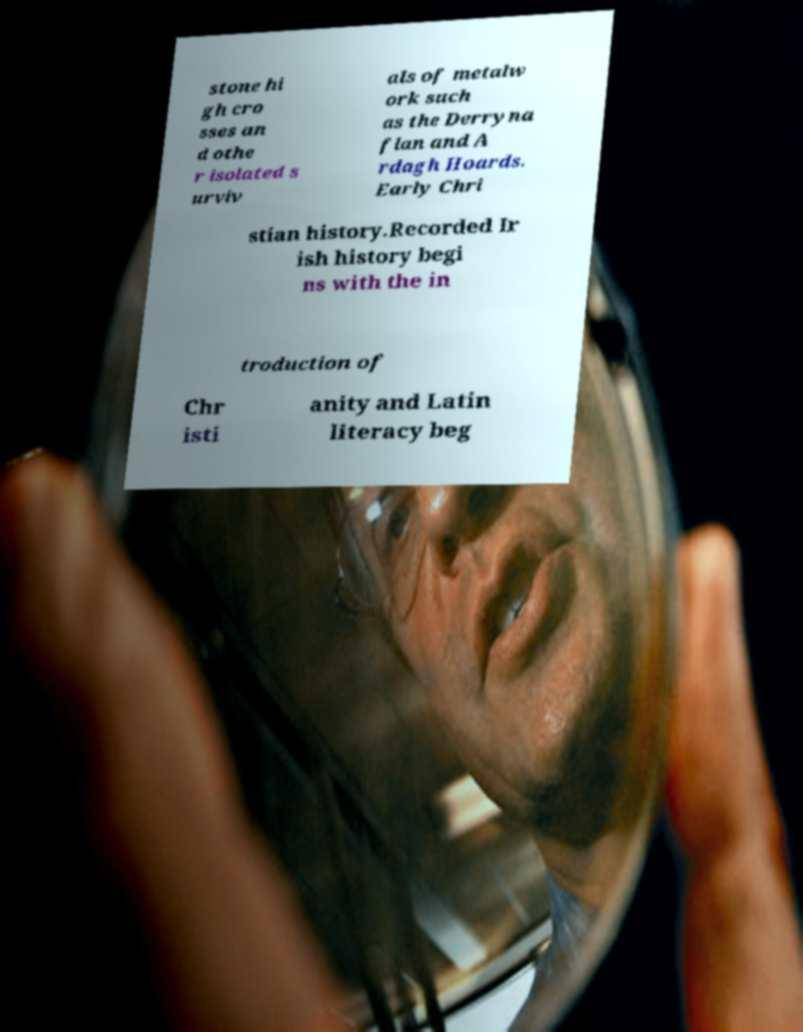I need the written content from this picture converted into text. Can you do that? stone hi gh cro sses an d othe r isolated s urviv als of metalw ork such as the Derryna flan and A rdagh Hoards. Early Chri stian history.Recorded Ir ish history begi ns with the in troduction of Chr isti anity and Latin literacy beg 